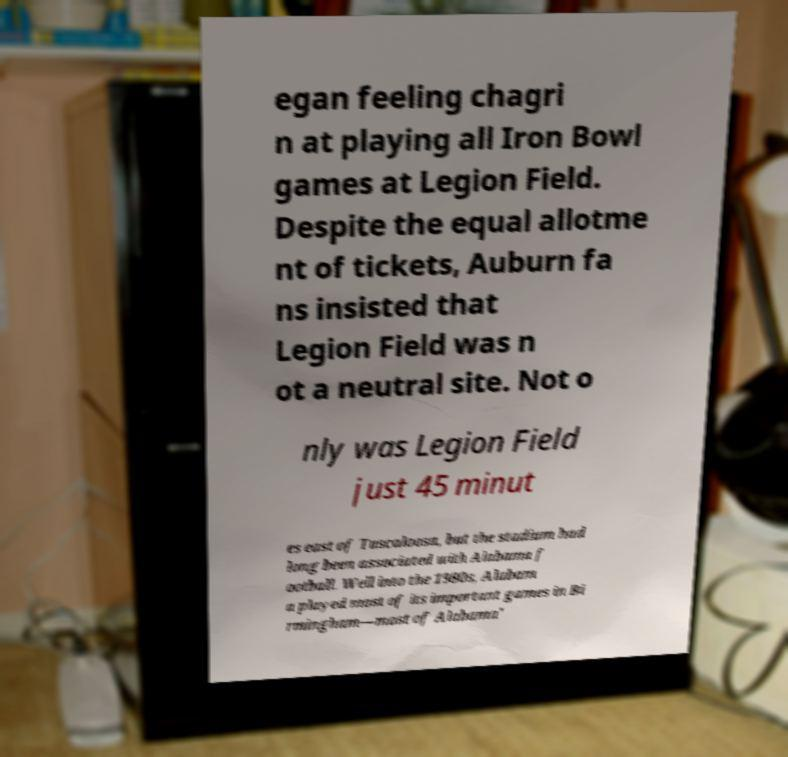Can you read and provide the text displayed in the image?This photo seems to have some interesting text. Can you extract and type it out for me? egan feeling chagri n at playing all Iron Bowl games at Legion Field. Despite the equal allotme nt of tickets, Auburn fa ns insisted that Legion Field was n ot a neutral site. Not o nly was Legion Field just 45 minut es east of Tuscaloosa, but the stadium had long been associated with Alabama f ootball. Well into the 1980s, Alabam a played most of its important games in Bi rmingham—most of Alabama' 